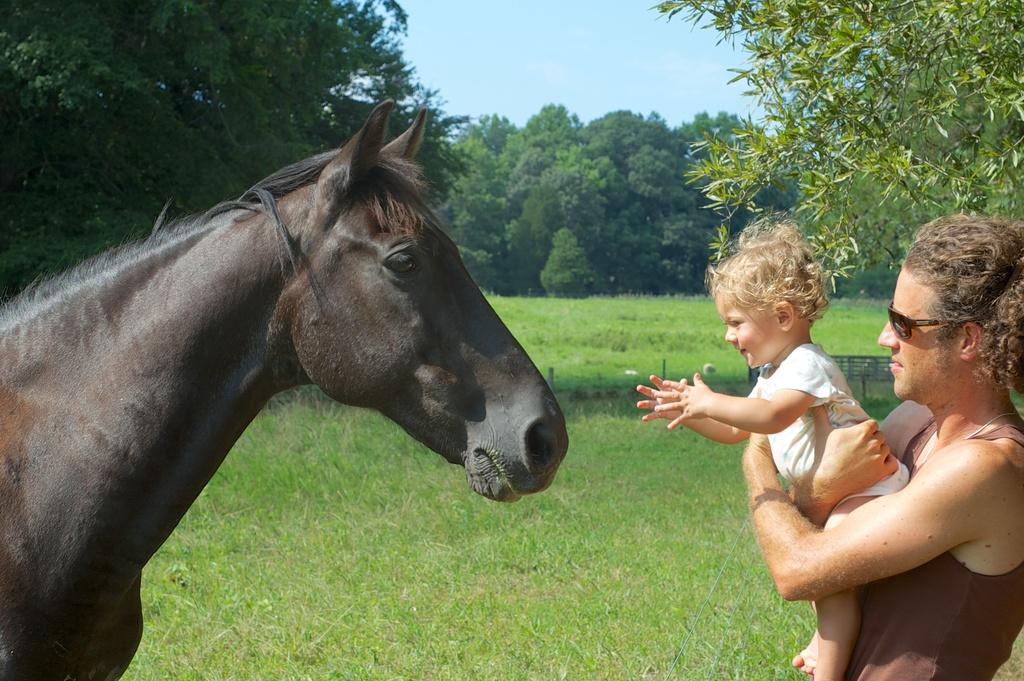What animal is present in the image? There is a horse in the image. Who else is present in the image besides the horse? There is a man and a kid in the image. What is the kid doing in the image? The kid is trying to touch the horse. What can be seen in the background of the image? There are trees and grass visible in the background of the image. What type of cake is being served to the horse in the image? There is no cake present in the image, and the horse is not being served any food. 